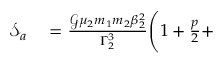Convert formula to latex. <formula><loc_0><loc_0><loc_500><loc_500>\begin{array} { r l } { \mathcal { S } _ { a } } & = \frac { \mathcal { G } \mu _ { 2 } m _ { 1 } m _ { 2 } \beta _ { 2 } ^ { 2 } } { \Gamma _ { 2 } ^ { 3 } } \Big ( 1 + \frac { p } { 2 } + } \end{array}</formula> 